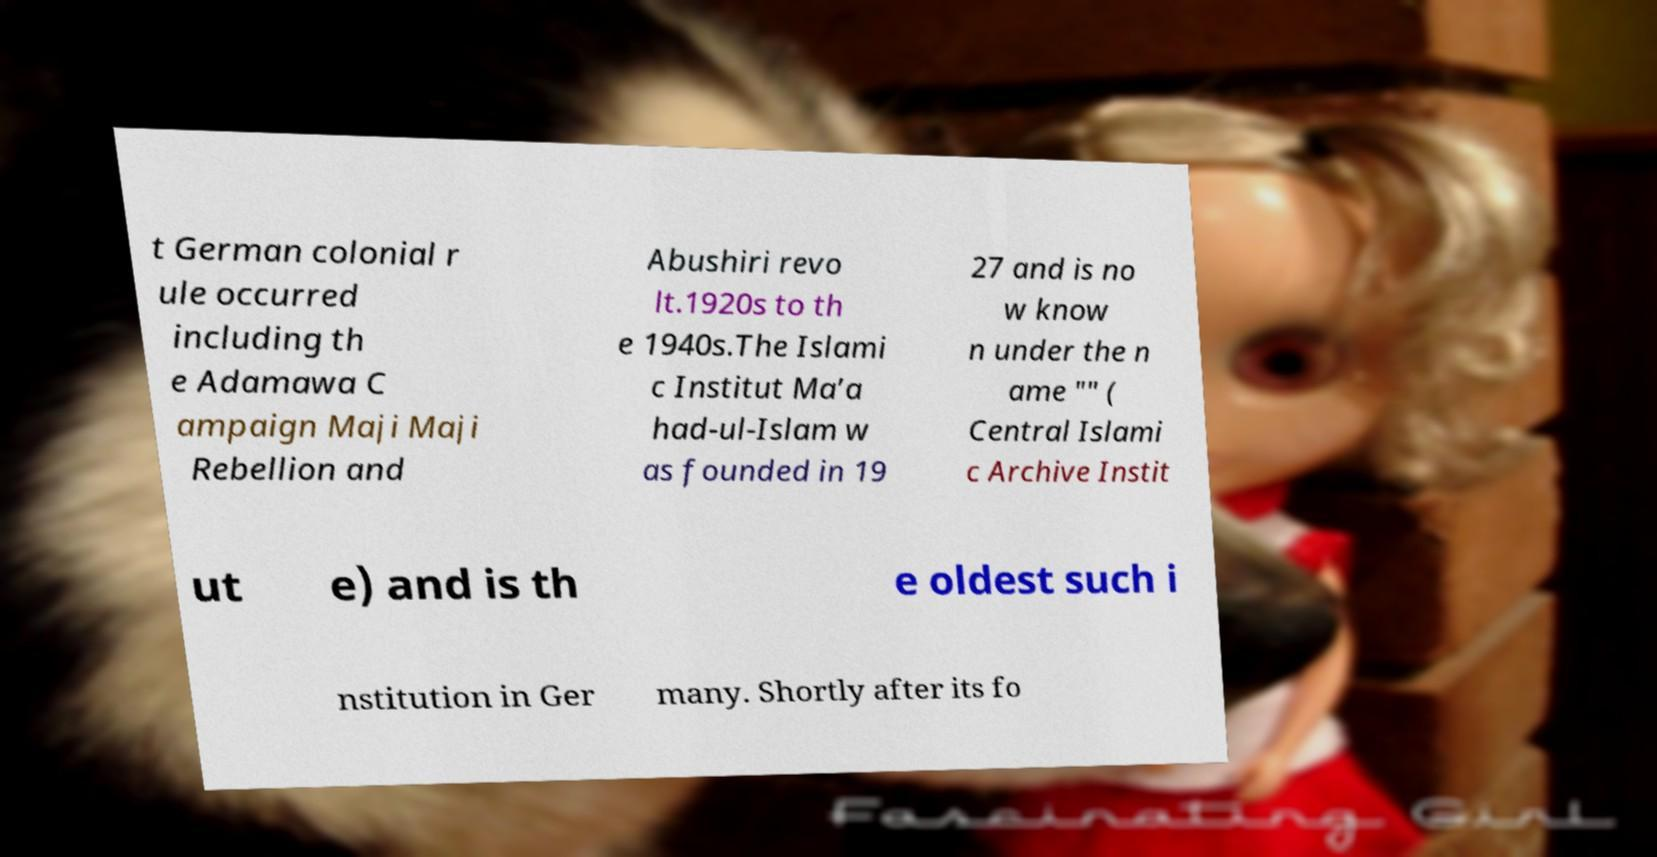Please identify and transcribe the text found in this image. t German colonial r ule occurred including th e Adamawa C ampaign Maji Maji Rebellion and Abushiri revo lt.1920s to th e 1940s.The Islami c Institut Ma’a had-ul-Islam w as founded in 19 27 and is no w know n under the n ame "" ( Central Islami c Archive Instit ut e) and is th e oldest such i nstitution in Ger many. Shortly after its fo 